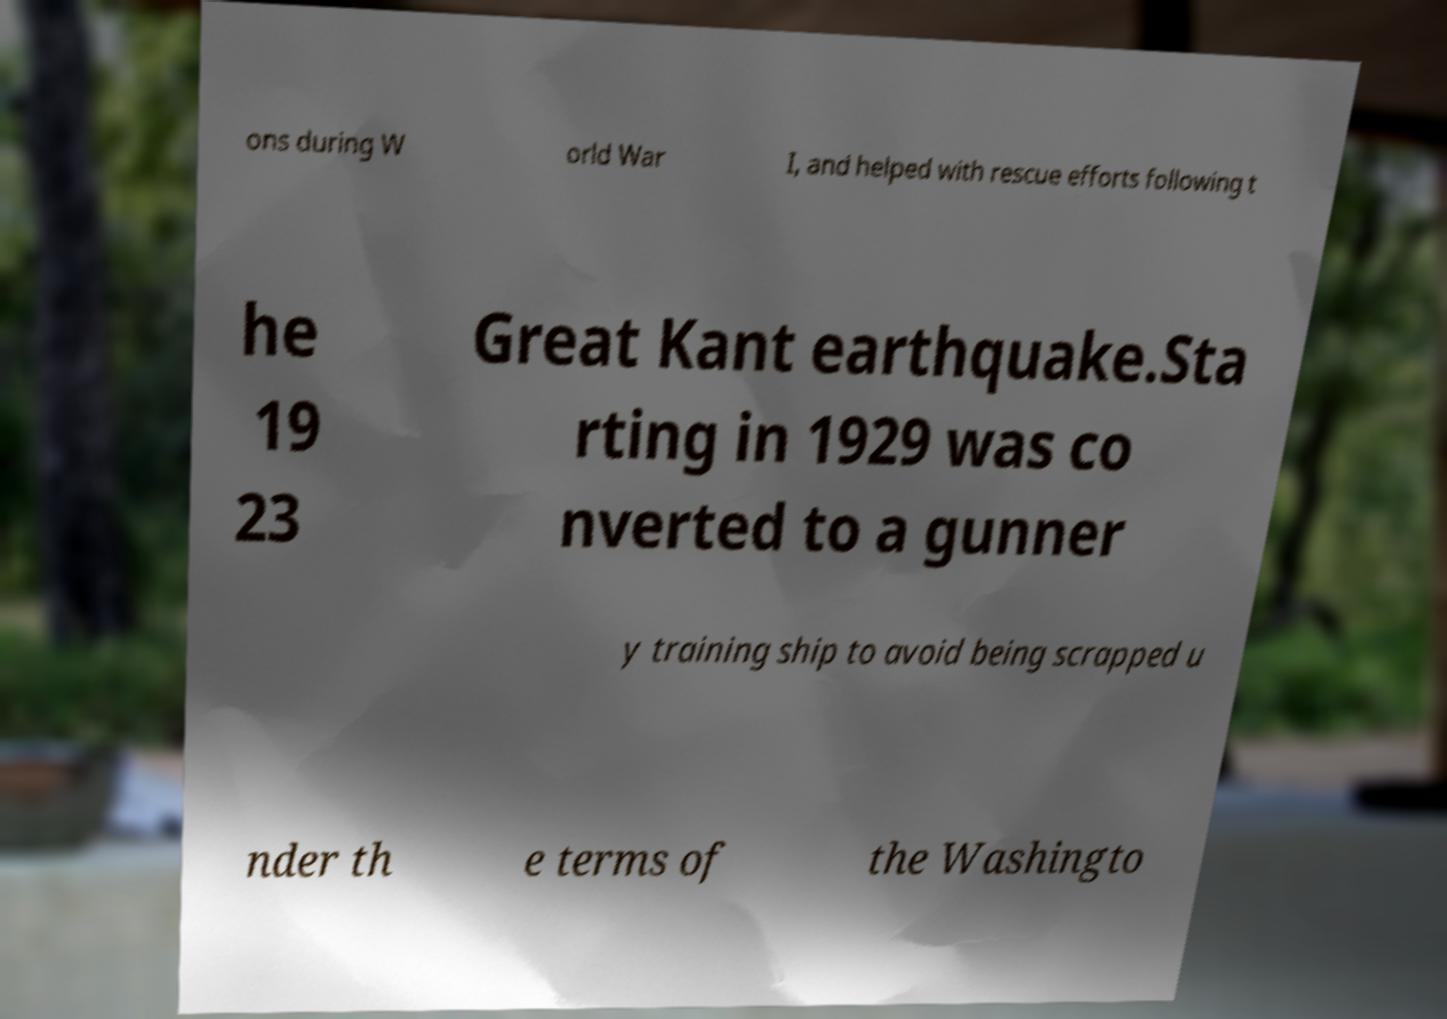Can you accurately transcribe the text from the provided image for me? ons during W orld War I, and helped with rescue efforts following t he 19 23 Great Kant earthquake.Sta rting in 1929 was co nverted to a gunner y training ship to avoid being scrapped u nder th e terms of the Washingto 